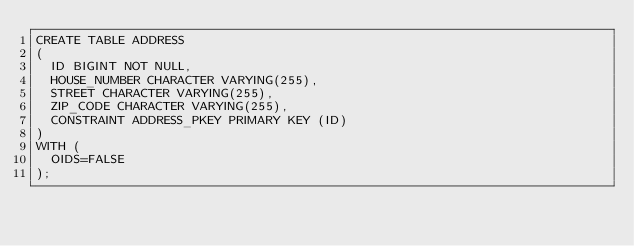<code> <loc_0><loc_0><loc_500><loc_500><_SQL_>CREATE TABLE ADDRESS
(
  ID BIGINT NOT NULL,
  HOUSE_NUMBER CHARACTER VARYING(255),
  STREET CHARACTER VARYING(255),
  ZIP_CODE CHARACTER VARYING(255),
  CONSTRAINT ADDRESS_PKEY PRIMARY KEY (ID)
)
WITH (
  OIDS=FALSE
);</code> 